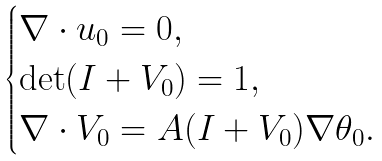Convert formula to latex. <formula><loc_0><loc_0><loc_500><loc_500>\begin{cases} \nabla \cdot u _ { 0 } = 0 , \\ \det ( I + V _ { 0 } ) = 1 , \\ \nabla \cdot V _ { 0 } = A ( I + V _ { 0 } ) \nabla \theta _ { 0 } . \end{cases}</formula> 